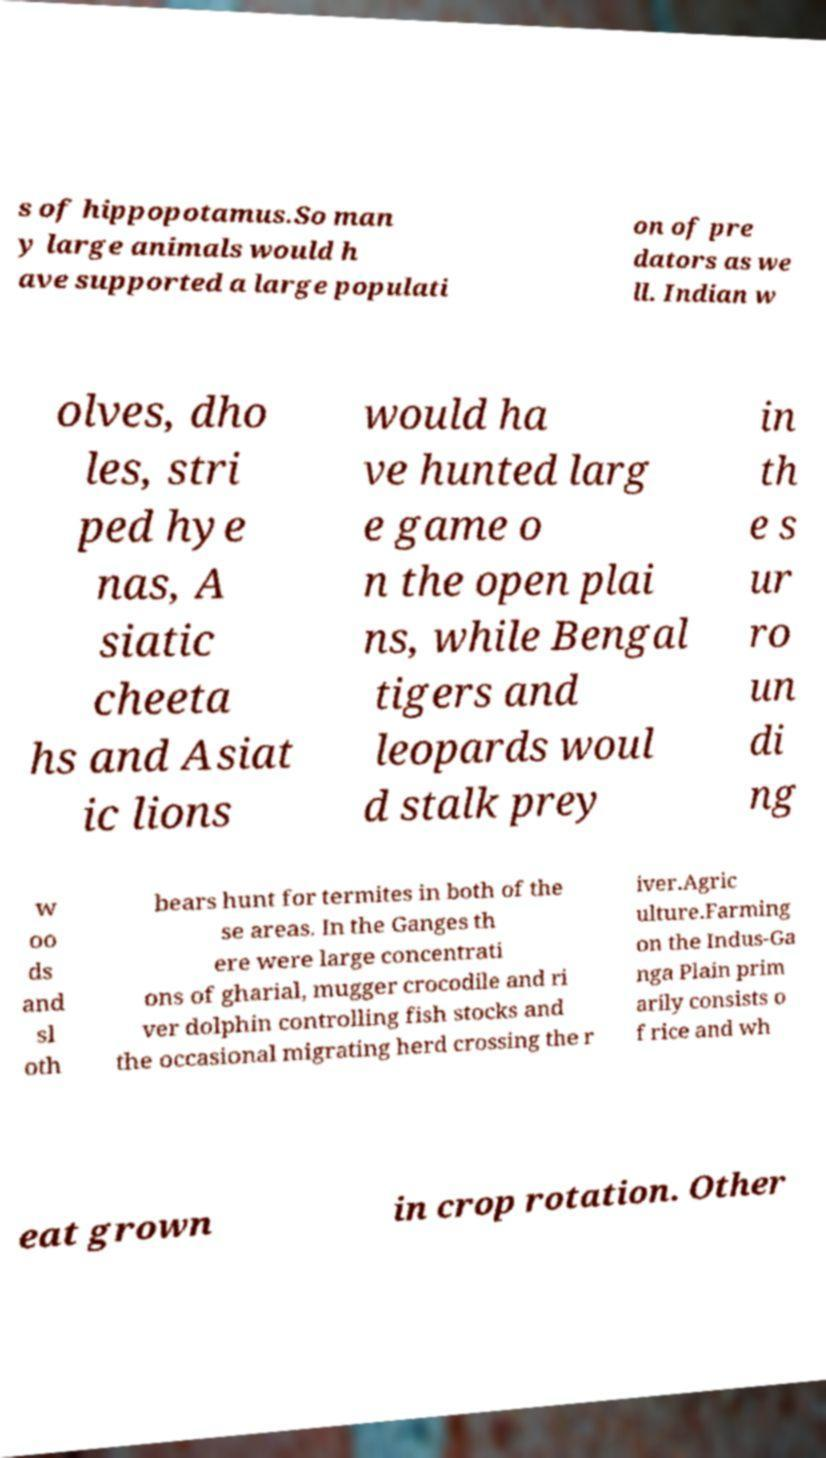I need the written content from this picture converted into text. Can you do that? s of hippopotamus.So man y large animals would h ave supported a large populati on of pre dators as we ll. Indian w olves, dho les, stri ped hye nas, A siatic cheeta hs and Asiat ic lions would ha ve hunted larg e game o n the open plai ns, while Bengal tigers and leopards woul d stalk prey in th e s ur ro un di ng w oo ds and sl oth bears hunt for termites in both of the se areas. In the Ganges th ere were large concentrati ons of gharial, mugger crocodile and ri ver dolphin controlling fish stocks and the occasional migrating herd crossing the r iver.Agric ulture.Farming on the Indus-Ga nga Plain prim arily consists o f rice and wh eat grown in crop rotation. Other 